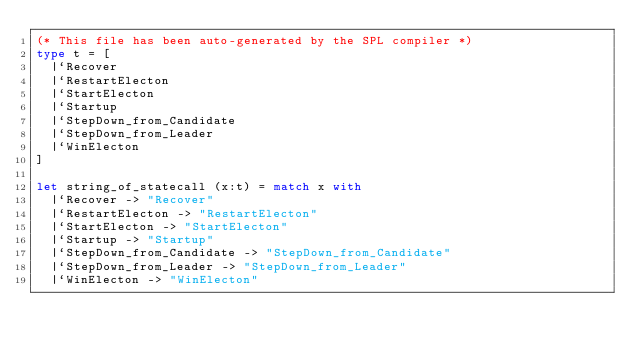Convert code to text. <code><loc_0><loc_0><loc_500><loc_500><_OCaml_>(* This file has been auto-generated by the SPL compiler *)
type t = [
  |`Recover
  |`RestartElecton
  |`StartElecton
  |`Startup
  |`StepDown_from_Candidate
  |`StepDown_from_Leader
  |`WinElecton
]

let string_of_statecall (x:t) = match x with
  |`Recover -> "Recover"
  |`RestartElecton -> "RestartElecton"
  |`StartElecton -> "StartElecton"
  |`Startup -> "Startup"
  |`StepDown_from_Candidate -> "StepDown_from_Candidate"
  |`StepDown_from_Leader -> "StepDown_from_Leader"
  |`WinElecton -> "WinElecton"

</code> 